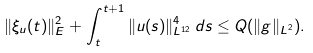Convert formula to latex. <formula><loc_0><loc_0><loc_500><loc_500>\| \xi _ { u } ( t ) \| ^ { 2 } _ { E } + \int _ { t } ^ { t + 1 } \| u ( s ) \| ^ { 4 } _ { L ^ { 1 2 } } \, d s \leq Q ( \| g \| _ { L ^ { 2 } } ) .</formula> 